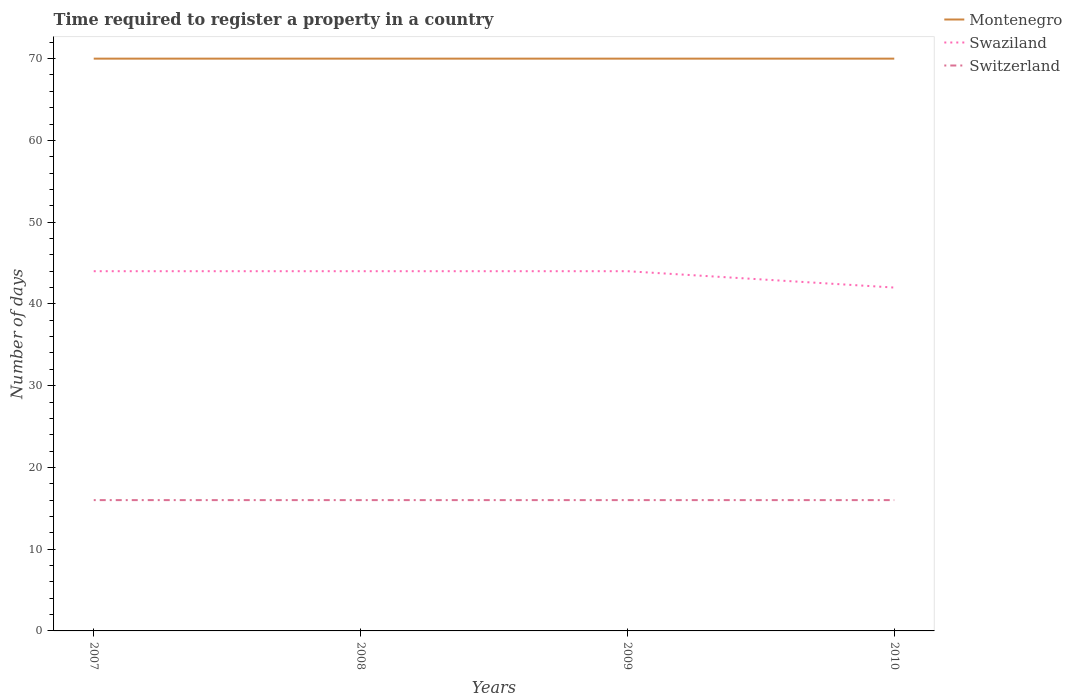How many different coloured lines are there?
Provide a short and direct response. 3. Does the line corresponding to Swaziland intersect with the line corresponding to Switzerland?
Offer a terse response. No. Is the number of lines equal to the number of legend labels?
Your answer should be very brief. Yes. In which year was the number of days required to register a property in Switzerland maximum?
Your answer should be very brief. 2007. Is the number of days required to register a property in Switzerland strictly greater than the number of days required to register a property in Montenegro over the years?
Ensure brevity in your answer.  Yes. Are the values on the major ticks of Y-axis written in scientific E-notation?
Your answer should be compact. No. Does the graph contain grids?
Offer a very short reply. No. Where does the legend appear in the graph?
Your response must be concise. Top right. How many legend labels are there?
Keep it short and to the point. 3. How are the legend labels stacked?
Your answer should be very brief. Vertical. What is the title of the graph?
Provide a short and direct response. Time required to register a property in a country. What is the label or title of the Y-axis?
Your response must be concise. Number of days. What is the Number of days of Montenegro in 2007?
Make the answer very short. 70. What is the Number of days in Swaziland in 2007?
Keep it short and to the point. 44. What is the Number of days in Switzerland in 2007?
Make the answer very short. 16. What is the Number of days in Montenegro in 2008?
Offer a very short reply. 70. What is the Number of days of Montenegro in 2009?
Your answer should be very brief. 70. What is the Number of days of Switzerland in 2009?
Offer a very short reply. 16. What is the Number of days in Montenegro in 2010?
Offer a terse response. 70. What is the Number of days in Swaziland in 2010?
Provide a short and direct response. 42. What is the Number of days of Switzerland in 2010?
Make the answer very short. 16. Across all years, what is the maximum Number of days of Switzerland?
Provide a short and direct response. 16. What is the total Number of days of Montenegro in the graph?
Your answer should be compact. 280. What is the total Number of days in Swaziland in the graph?
Ensure brevity in your answer.  174. What is the difference between the Number of days in Swaziland in 2007 and that in 2008?
Provide a succinct answer. 0. What is the difference between the Number of days of Montenegro in 2007 and that in 2009?
Your response must be concise. 0. What is the difference between the Number of days of Switzerland in 2007 and that in 2009?
Offer a very short reply. 0. What is the difference between the Number of days of Montenegro in 2007 and that in 2010?
Keep it short and to the point. 0. What is the difference between the Number of days of Switzerland in 2007 and that in 2010?
Make the answer very short. 0. What is the difference between the Number of days of Montenegro in 2008 and that in 2009?
Provide a succinct answer. 0. What is the difference between the Number of days of Switzerland in 2008 and that in 2010?
Your answer should be very brief. 0. What is the difference between the Number of days in Montenegro in 2009 and that in 2010?
Your answer should be very brief. 0. What is the difference between the Number of days in Switzerland in 2009 and that in 2010?
Offer a very short reply. 0. What is the difference between the Number of days of Swaziland in 2007 and the Number of days of Switzerland in 2009?
Ensure brevity in your answer.  28. What is the difference between the Number of days of Montenegro in 2007 and the Number of days of Switzerland in 2010?
Give a very brief answer. 54. What is the difference between the Number of days of Montenegro in 2008 and the Number of days of Swaziland in 2009?
Your answer should be very brief. 26. What is the difference between the Number of days of Swaziland in 2008 and the Number of days of Switzerland in 2009?
Provide a succinct answer. 28. What is the difference between the Number of days in Montenegro in 2008 and the Number of days in Switzerland in 2010?
Provide a succinct answer. 54. What is the difference between the Number of days in Swaziland in 2008 and the Number of days in Switzerland in 2010?
Provide a succinct answer. 28. What is the difference between the Number of days in Montenegro in 2009 and the Number of days in Swaziland in 2010?
Your answer should be compact. 28. What is the difference between the Number of days in Montenegro in 2009 and the Number of days in Switzerland in 2010?
Provide a short and direct response. 54. What is the difference between the Number of days in Swaziland in 2009 and the Number of days in Switzerland in 2010?
Your answer should be very brief. 28. What is the average Number of days in Swaziland per year?
Ensure brevity in your answer.  43.5. What is the average Number of days of Switzerland per year?
Provide a succinct answer. 16. In the year 2007, what is the difference between the Number of days of Montenegro and Number of days of Swaziland?
Your answer should be compact. 26. In the year 2007, what is the difference between the Number of days of Montenegro and Number of days of Switzerland?
Keep it short and to the point. 54. In the year 2007, what is the difference between the Number of days in Swaziland and Number of days in Switzerland?
Provide a short and direct response. 28. In the year 2008, what is the difference between the Number of days of Montenegro and Number of days of Switzerland?
Offer a very short reply. 54. In the year 2009, what is the difference between the Number of days in Montenegro and Number of days in Swaziland?
Ensure brevity in your answer.  26. In the year 2009, what is the difference between the Number of days of Montenegro and Number of days of Switzerland?
Your response must be concise. 54. In the year 2009, what is the difference between the Number of days of Swaziland and Number of days of Switzerland?
Offer a terse response. 28. In the year 2010, what is the difference between the Number of days in Montenegro and Number of days in Swaziland?
Offer a terse response. 28. What is the ratio of the Number of days in Switzerland in 2007 to that in 2008?
Give a very brief answer. 1. What is the ratio of the Number of days in Swaziland in 2007 to that in 2009?
Your answer should be very brief. 1. What is the ratio of the Number of days of Switzerland in 2007 to that in 2009?
Provide a succinct answer. 1. What is the ratio of the Number of days in Montenegro in 2007 to that in 2010?
Keep it short and to the point. 1. What is the ratio of the Number of days in Swaziland in 2007 to that in 2010?
Provide a succinct answer. 1.05. What is the ratio of the Number of days in Switzerland in 2008 to that in 2009?
Your response must be concise. 1. What is the ratio of the Number of days of Swaziland in 2008 to that in 2010?
Make the answer very short. 1.05. What is the ratio of the Number of days in Montenegro in 2009 to that in 2010?
Provide a succinct answer. 1. What is the ratio of the Number of days of Swaziland in 2009 to that in 2010?
Give a very brief answer. 1.05. What is the difference between the highest and the second highest Number of days in Switzerland?
Keep it short and to the point. 0. What is the difference between the highest and the lowest Number of days of Swaziland?
Provide a succinct answer. 2. 